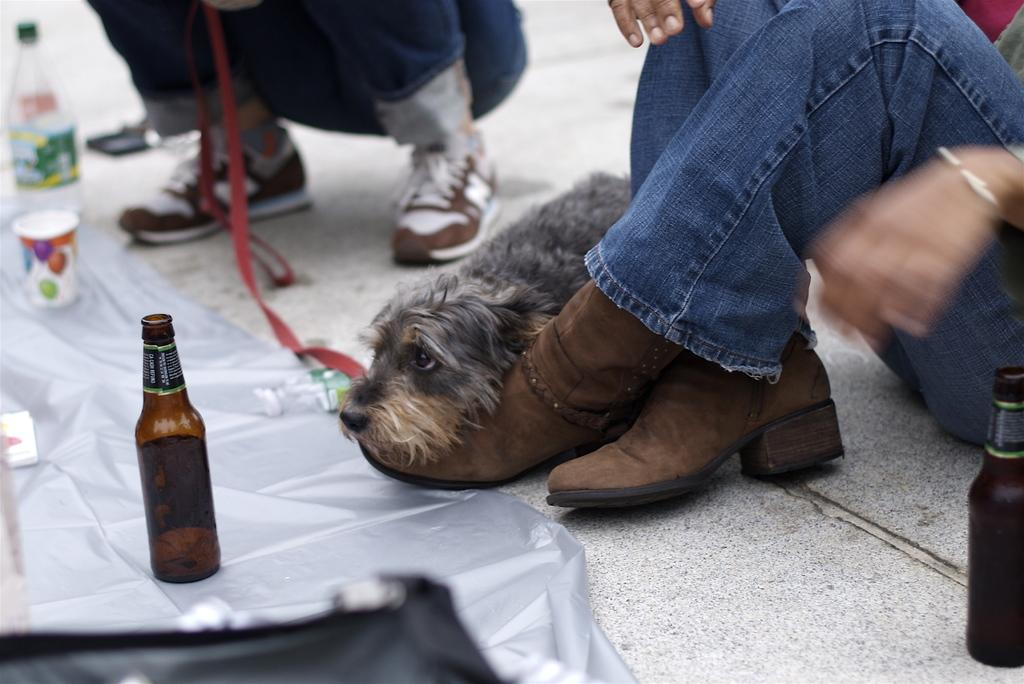What type of containers can be seen in the image? There are bottles in the image. What is the glass placed on in the image? The glass is on a cover in the image. Can you identify a specific type of bottle in the image? Yes, there is a water bottle in the image. What is present on the floor in the image? There is a puppy on the floor in the image. How many people are in the image? There are two persons in the image. What type of bubble can be seen in the image? There is no bubble present in the image. Is there a bell ringing in the image? There is no bell present in the image. 